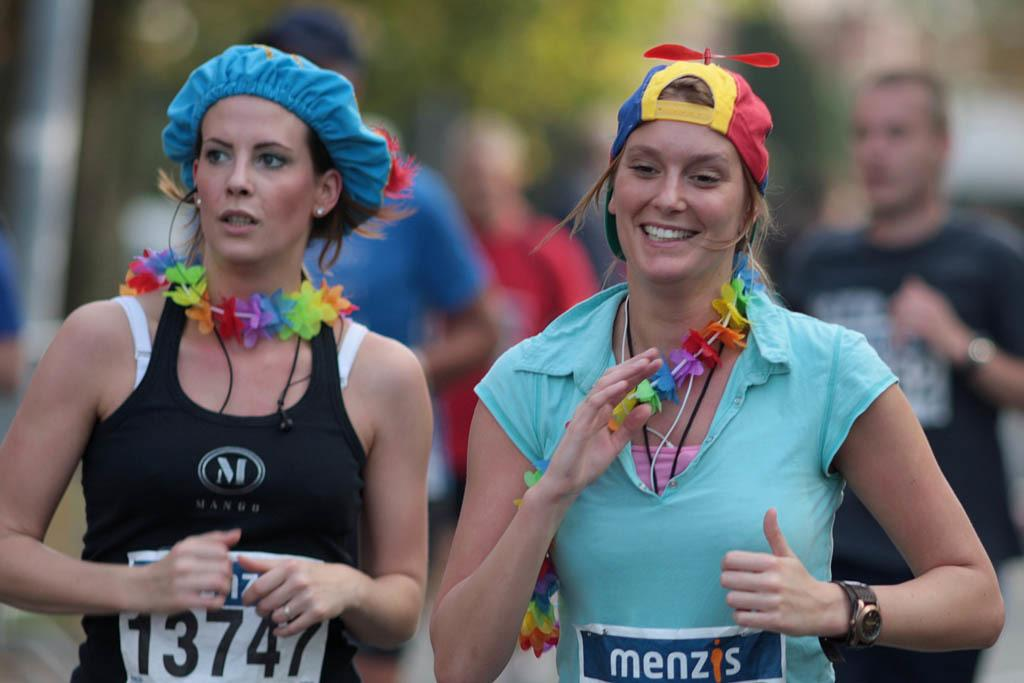How many women are in the foreground of the image? There are two women in the foreground of the image. What are the women wearing on their heads? The women are wearing hats. Can you describe the facial expression of one of the women? One of the women is smiling. What can be seen in the background of the image? There are people in the background of the image. How would you describe the appearance of the background? The background appears to be blurry. What type of rod is being used by the women to limit their movements in the image? There is no rod present in the image, and the women are not being limited in their movements. 